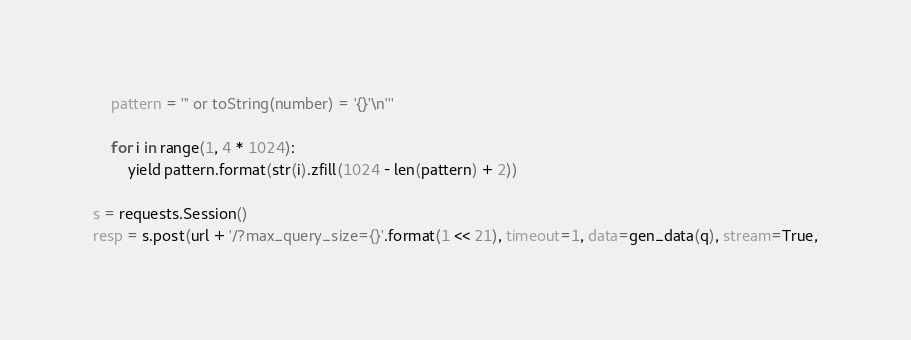<code> <loc_0><loc_0><loc_500><loc_500><_Bash_>    pattern = ''' or toString(number) = '{}'\n'''

    for i in range(1, 4 * 1024):
        yield pattern.format(str(i).zfill(1024 - len(pattern) + 2))

s = requests.Session()
resp = s.post(url + '/?max_query_size={}'.format(1 << 21), timeout=1, data=gen_data(q), stream=True,</code> 